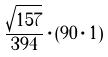<formula> <loc_0><loc_0><loc_500><loc_500>\frac { \sqrt { 1 5 7 } } { 3 9 4 } \cdot ( 9 0 \cdot 1 )</formula> 